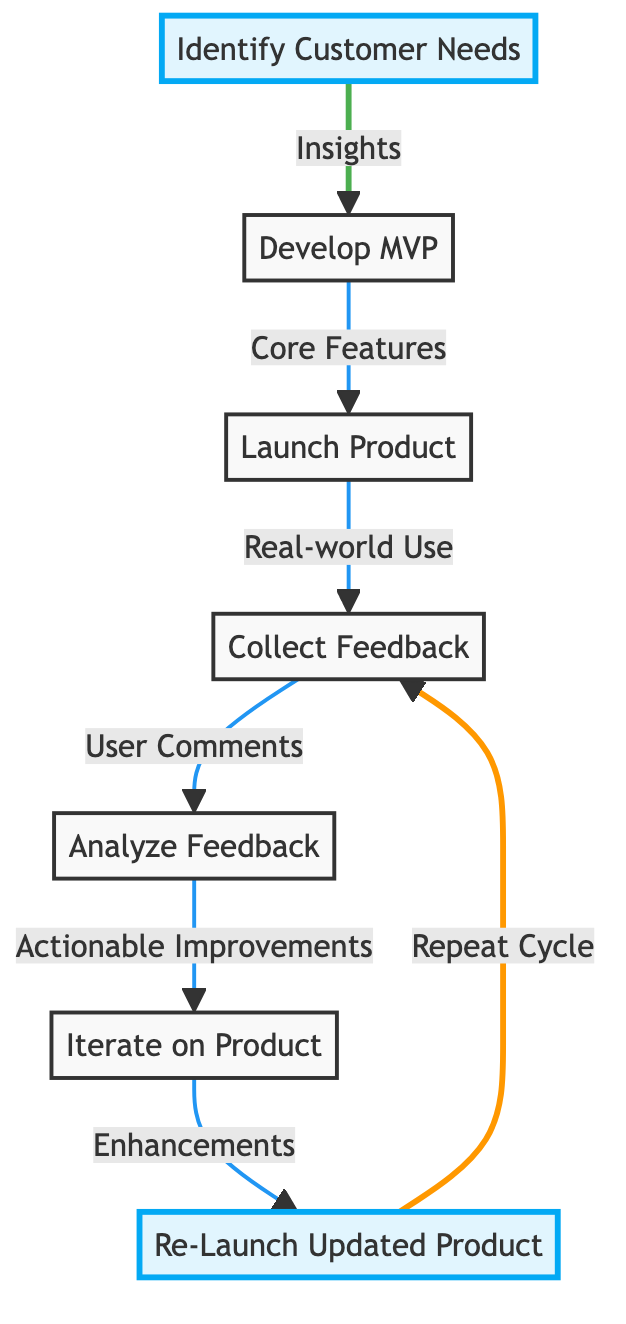What is the first step in the feedback loop? The first step is labeled "Identify Customer Needs", which is the initial action taken to gather insights on customer expectations.
Answer: Identify Customer Needs How many nodes are in the diagram? By counting each unique labeled step in the flowchart, we find there are 7 nodes total corresponding to distinct actions in the feedback process.
Answer: 7 What phrase connects "Collect Feedback" to "Analyze Feedback"? The connection is labeled "User Comments", indicating that feedback collected from users is analyzed next.
Answer: User Comments Which node follows "Iterate on Product"? The next step in the sequence after "Iterate on Product" is "Re-Launch Updated Product", as indicated by the flow.
Answer: Re-Launch Updated Product What are the two highlighted nodes in the diagram? The highlighted nodes are "Identify Customer Needs" and "Re-Launch Updated Product", emphasizing the start and end of the feedback loop.
Answer: Identify Customer Needs, Re-Launch Updated Product What type of product is to be developed based on customer insights? The type of product to be developed is a "Minimum Viable Product", which focuses on testing core features identified through customer needs.
Answer: Minimum Viable Product What comes after "Launch Product"? The step that follows "Launch Product" is "Collect Feedback", showing the discourse between product launch and gathering user responses.
Answer: Collect Feedback What is the relationship between "Analyze Feedback" and "Iterate on Product"? The relationship is denoted by "Actionable Improvements", indicating that the analysis leads to actionable changes in the product.
Answer: Actionable Improvements What is the function of "Re-Launch Updated Product" in the cycle? It serves the function of initiating a repeat in the cycle by releasing an improved product version to get feedback again.
Answer: Repeat Cycle 